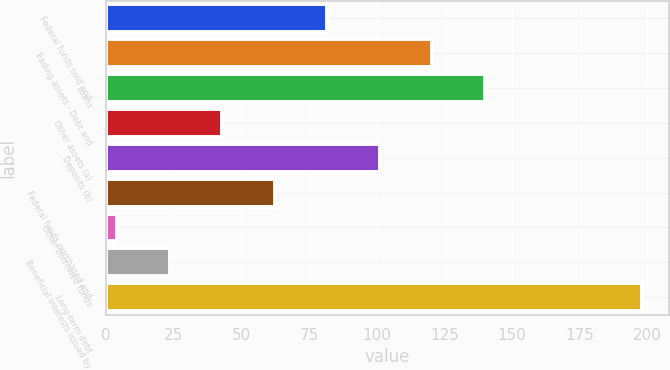Convert chart. <chart><loc_0><loc_0><loc_500><loc_500><bar_chart><fcel>Federal funds sold and<fcel>Trading assets - Debt and<fcel>Loans<fcel>Other assets (a)<fcel>Deposits (b)<fcel>Federal funds purchased and<fcel>Other borrowed funds<fcel>Beneficial interests issued by<fcel>Long-term debt<nl><fcel>81.6<fcel>120.4<fcel>139.8<fcel>42.8<fcel>101<fcel>62.2<fcel>4<fcel>23.4<fcel>198<nl></chart> 